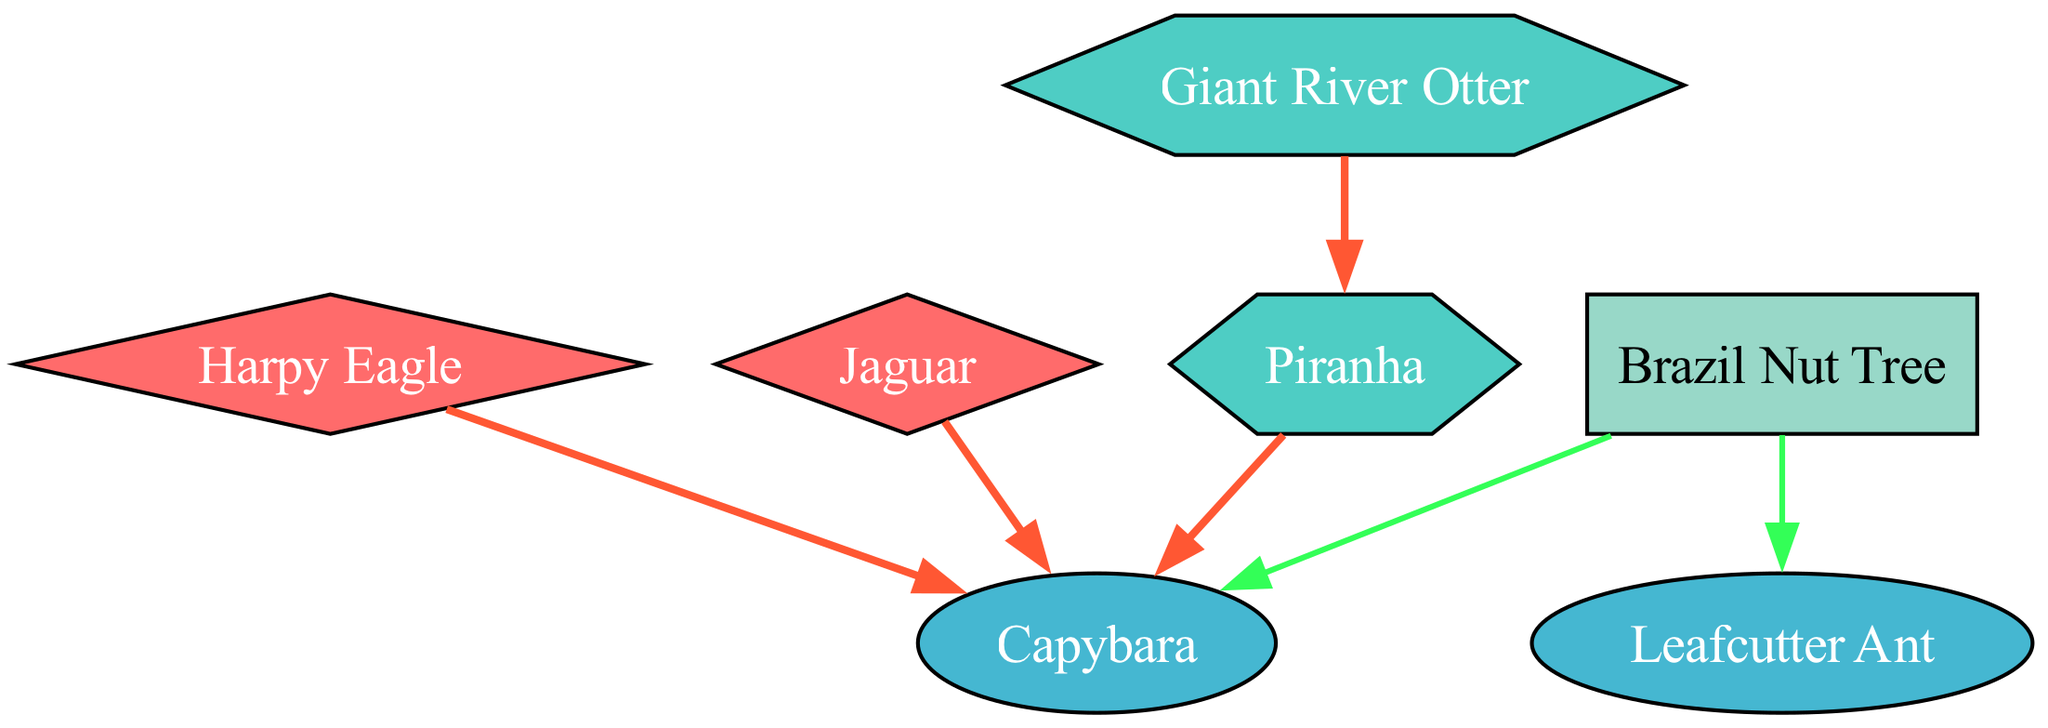What is the number of apex predators in the food chain? In the diagram, I can identify two apex predators: the Harpy Eagle and the Jaguar. Each of these species is labeled as an apex predator, thus the total count is two.
Answer: 2 Which organism is preyed upon by both the Harpy Eagle and the Jaguar? Looking at the relationships, both the Harpy Eagle and the Jaguar have a directed edge pointing to the Capybara, indicating that they prey on it. Hence, the answer is the Capybara.
Answer: Capybara How many herbivores are in the food chain? By analyzing the list of organisms, the Capybara and the Leafcutter Ant are classified as herbivores. Counting these gives a total of two herbivores in the food chain.
Answer: 2 What is the primary producer in this ecosystem? The diagram lists the Brazil Nut Tree explicitly as a producer. Since there's no other producer mentioned, this is identified as the primary producer in the ecosystem.
Answer: Brazil Nut Tree Which carnivore preys on the Piranha? A review of the relationships reveals that the Giant River Otter is the only carnivore that preys on the Piranha. This can be confirmed as the directed edge indicates this specific relationship.
Answer: Giant River Otter What role does the Capybara play in this food chain? The Capybara is categorized in the diagram as an herbivore, and it also serves as prey for multiple predators, which means it plays a dual role as both a consumer of plants and a food source for these predators.
Answer: Herbivore How does the Leafcutter Ant obtain its food? The Leafcutter Ant obtains its food by consuming the Brazil Nut Tree, as evidenced by the directed edge from the Brazil Nut Tree to the Leafcutter Ant in the relationships section of the diagram.
Answer: Brazil Nut Tree Which organism is at the top of the food chain? The top of the food chain is represented by the apex predators, which include both the Harpy Eagle and the Jaguar. Among these, they represent the highest levels of the food chain due to their predatory nature.
Answer: Harpy Eagle, Jaguar 